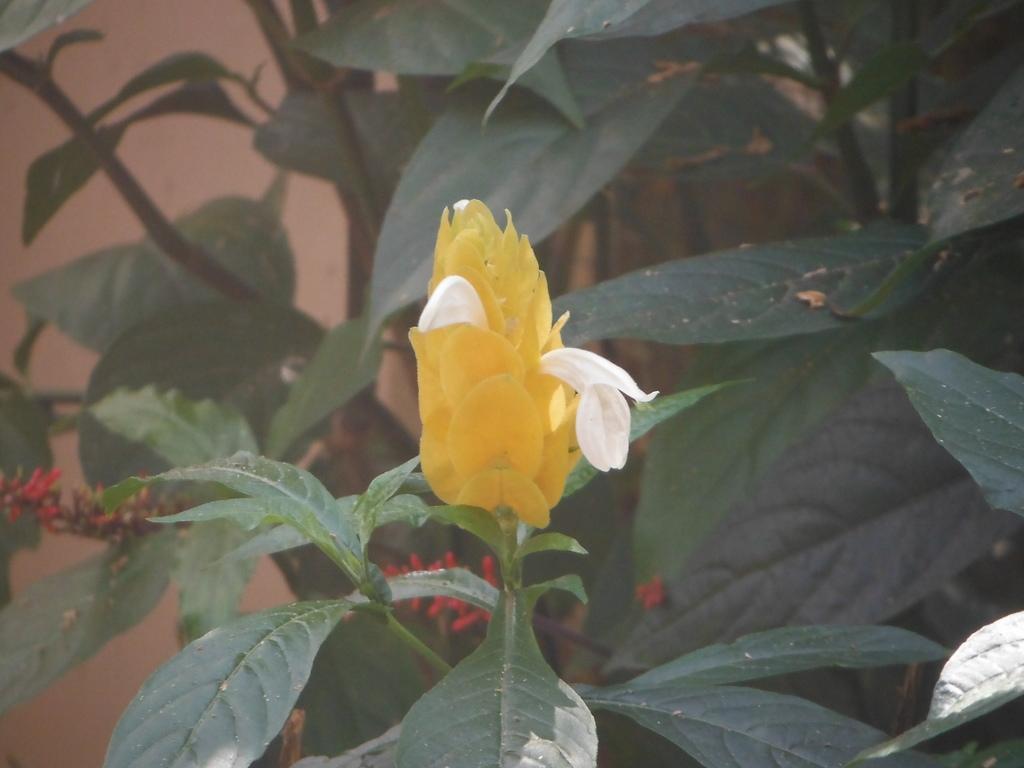How would you summarize this image in a sentence or two? In the image there is a plant with leaves and a flower. And also there are red color buds. 